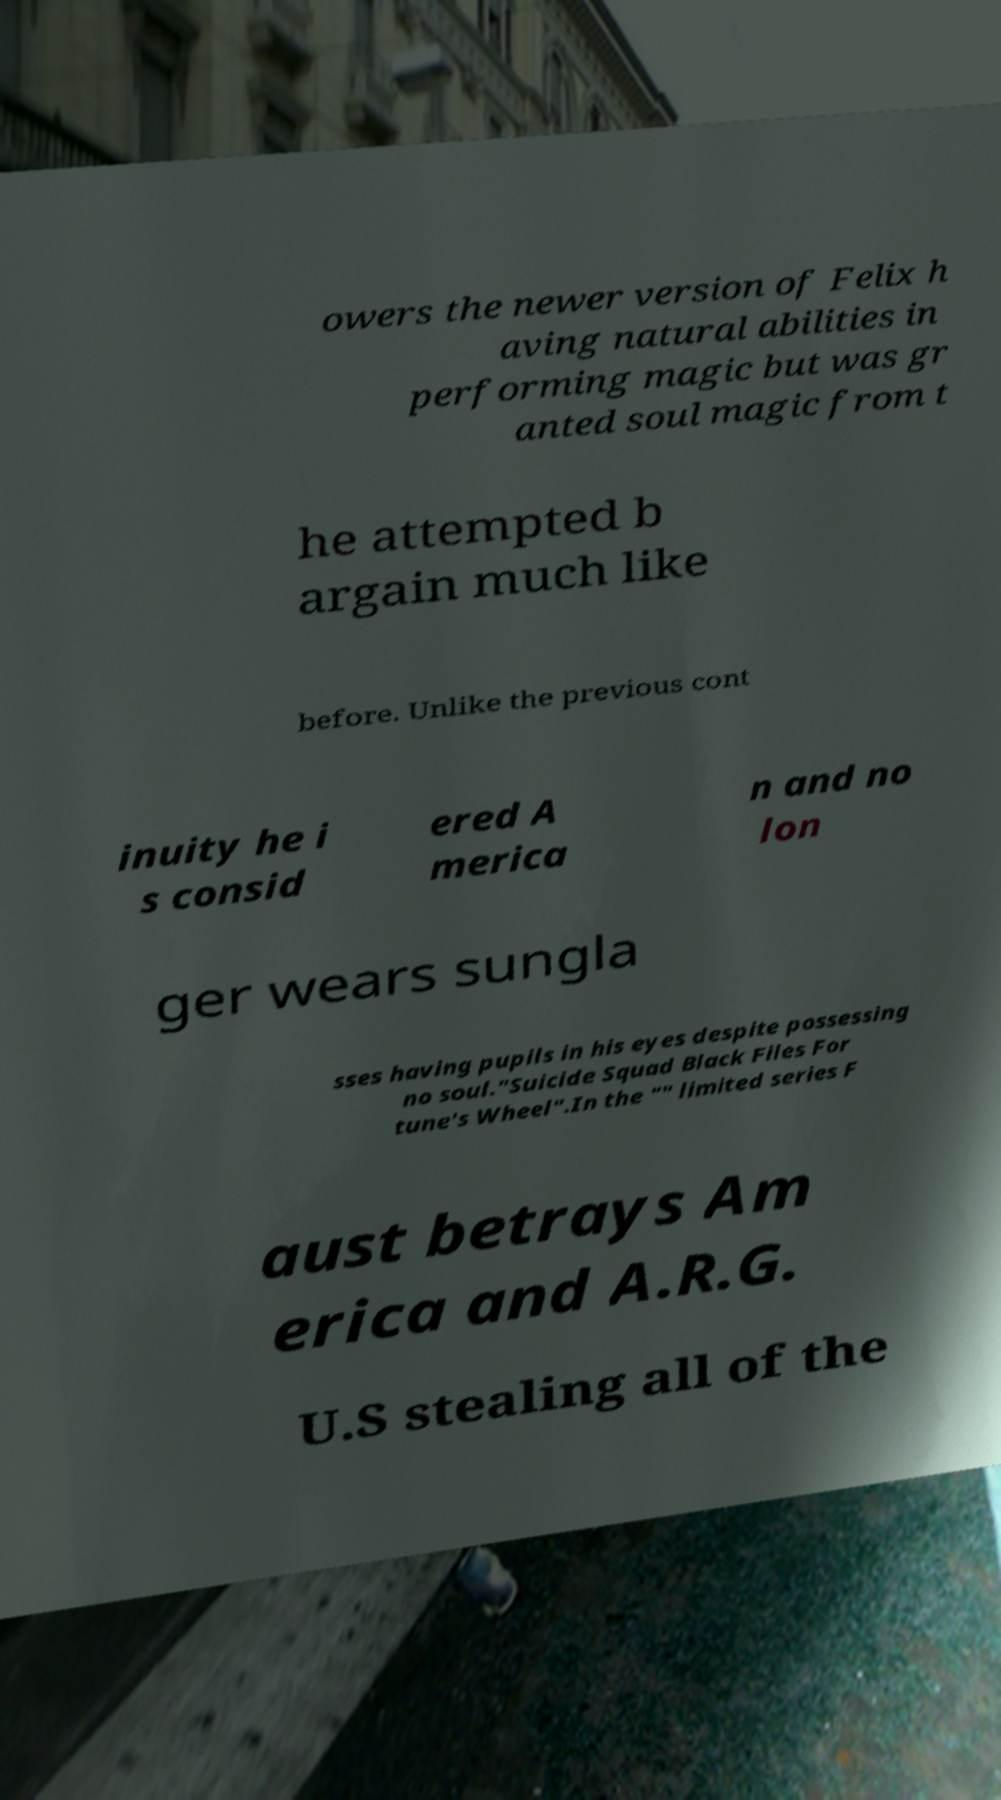Could you extract and type out the text from this image? owers the newer version of Felix h aving natural abilities in performing magic but was gr anted soul magic from t he attempted b argain much like before. Unlike the previous cont inuity he i s consid ered A merica n and no lon ger wears sungla sses having pupils in his eyes despite possessing no soul."Suicide Squad Black Files For tune's Wheel".In the "" limited series F aust betrays Am erica and A.R.G. U.S stealing all of the 